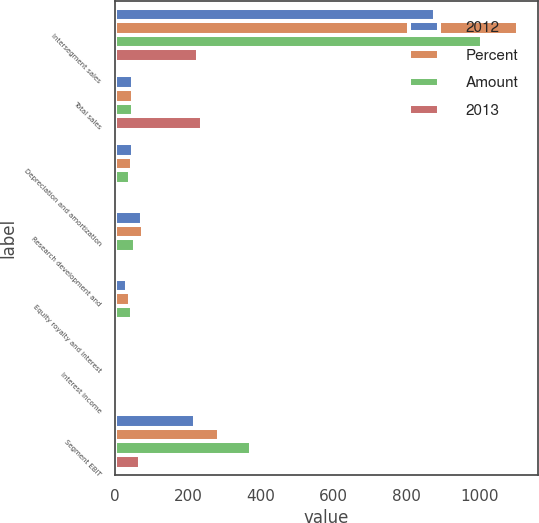Convert chart. <chart><loc_0><loc_0><loc_500><loc_500><stacked_bar_chart><ecel><fcel>Intersegment sales<fcel>Total sales<fcel>Depreciation and amortization<fcel>Research development and<fcel>Equity royalty and interest<fcel>Interest income<fcel>Segment EBIT<nl><fcel>2012<fcel>877<fcel>50<fcel>50<fcel>73<fcel>32<fcel>6<fcel>218<nl><fcel>Percent<fcel>1105<fcel>50<fcel>47<fcel>76<fcel>40<fcel>9<fcel>285<nl><fcel>Amount<fcel>1006<fcel>50<fcel>42<fcel>54<fcel>47<fcel>8<fcel>373<nl><fcel>2013<fcel>228<fcel>237<fcel>3<fcel>3<fcel>8<fcel>3<fcel>67<nl></chart> 